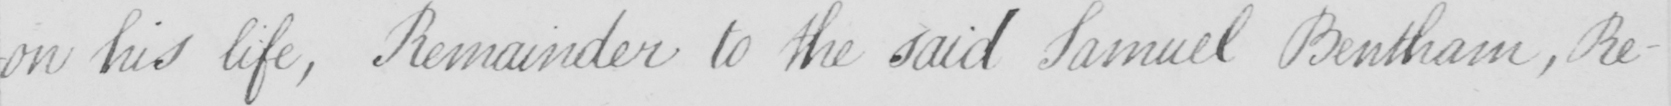Can you read and transcribe this handwriting? -on his life , Remainder to the said Samuel Bentham , Re- 